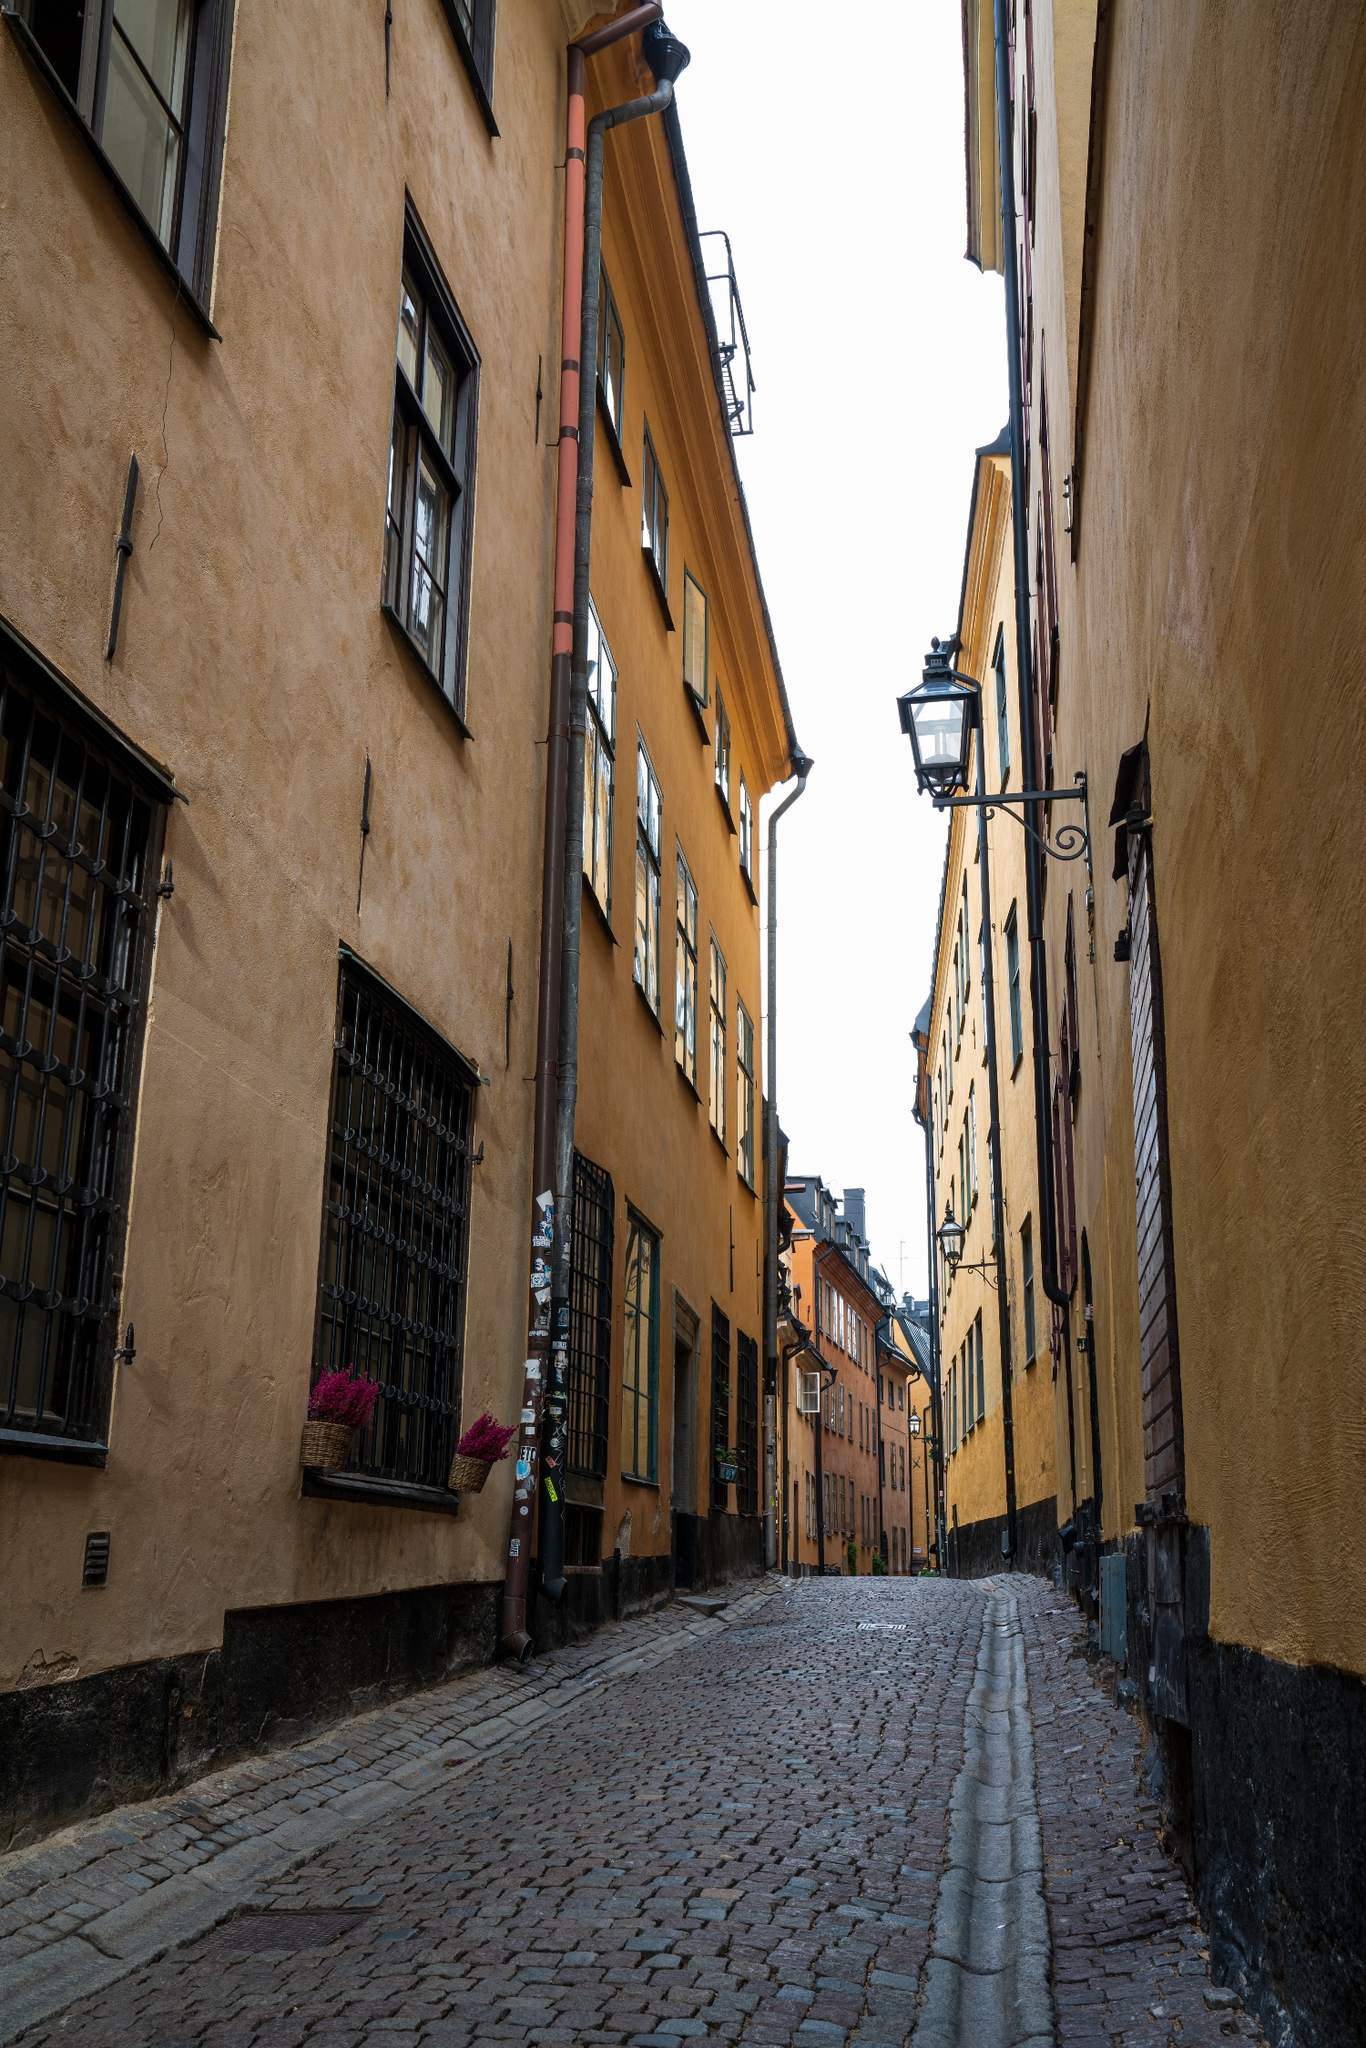What historical significance might this street hold in its city? This street, with its traditional architecture and cobblestones, likely holds significant historical value. It may have been part of the original city planning several hundred years ago, serving as a residential or commercial hub. The preserved state of the buildings suggests a commitment to maintaining its historical appearance, which can be indicative of the area’s importance in the city’s past, perhaps linked to trade or local urban development. 